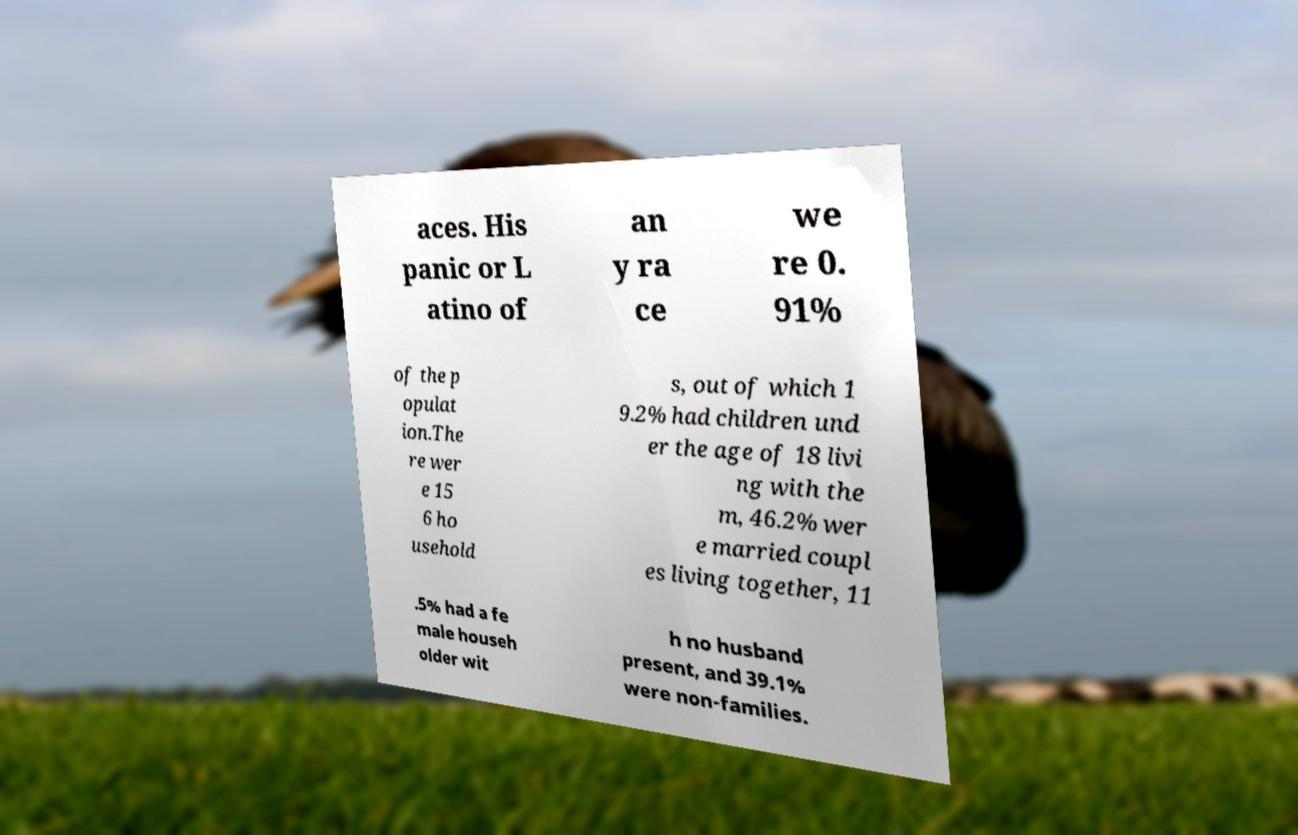For documentation purposes, I need the text within this image transcribed. Could you provide that? aces. His panic or L atino of an y ra ce we re 0. 91% of the p opulat ion.The re wer e 15 6 ho usehold s, out of which 1 9.2% had children und er the age of 18 livi ng with the m, 46.2% wer e married coupl es living together, 11 .5% had a fe male househ older wit h no husband present, and 39.1% were non-families. 